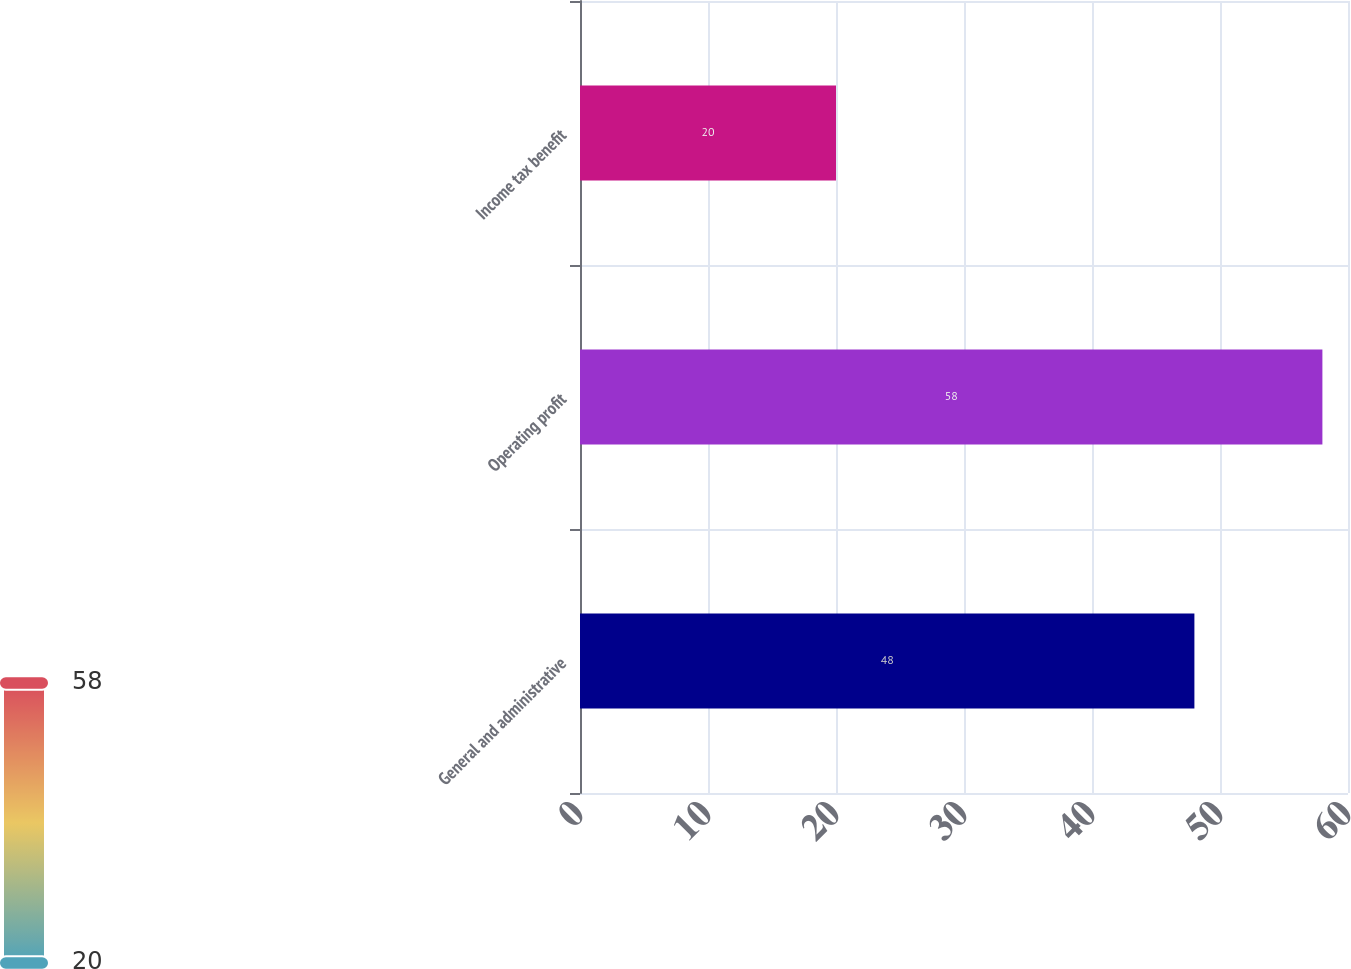Convert chart. <chart><loc_0><loc_0><loc_500><loc_500><bar_chart><fcel>General and administrative<fcel>Operating profit<fcel>Income tax benefit<nl><fcel>48<fcel>58<fcel>20<nl></chart> 